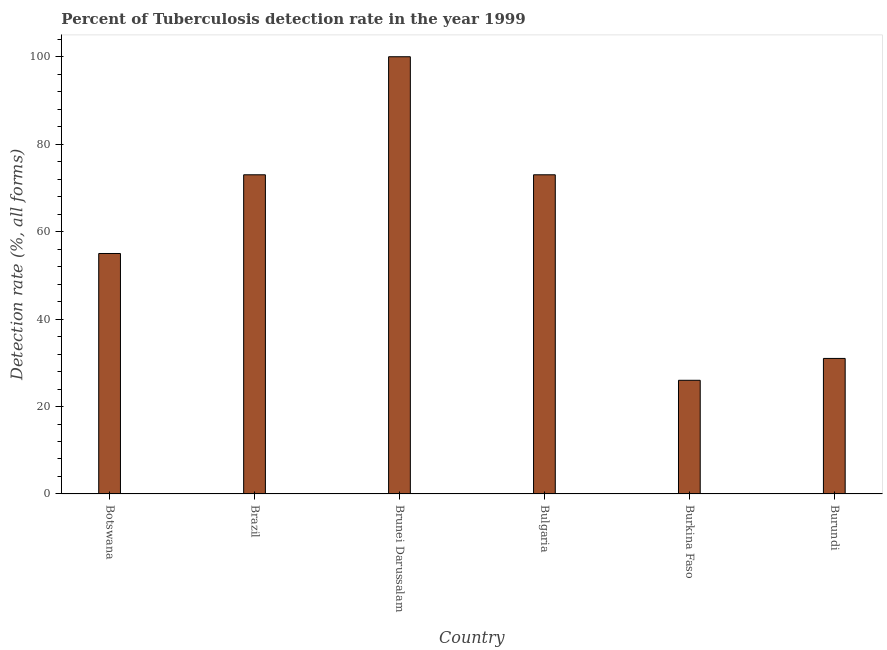Does the graph contain any zero values?
Offer a terse response. No. Does the graph contain grids?
Your answer should be very brief. No. What is the title of the graph?
Ensure brevity in your answer.  Percent of Tuberculosis detection rate in the year 1999. What is the label or title of the Y-axis?
Provide a short and direct response. Detection rate (%, all forms). What is the detection rate of tuberculosis in Bulgaria?
Offer a very short reply. 73. Across all countries, what is the maximum detection rate of tuberculosis?
Give a very brief answer. 100. Across all countries, what is the minimum detection rate of tuberculosis?
Your answer should be very brief. 26. In which country was the detection rate of tuberculosis maximum?
Make the answer very short. Brunei Darussalam. In which country was the detection rate of tuberculosis minimum?
Make the answer very short. Burkina Faso. What is the sum of the detection rate of tuberculosis?
Offer a very short reply. 358. What is the difference between the detection rate of tuberculosis in Botswana and Brunei Darussalam?
Your response must be concise. -45. What is the average detection rate of tuberculosis per country?
Offer a terse response. 59.67. What is the median detection rate of tuberculosis?
Offer a terse response. 64. In how many countries, is the detection rate of tuberculosis greater than 36 %?
Provide a short and direct response. 4. What is the ratio of the detection rate of tuberculosis in Botswana to that in Bulgaria?
Give a very brief answer. 0.75. What is the difference between the highest and the lowest detection rate of tuberculosis?
Your response must be concise. 74. In how many countries, is the detection rate of tuberculosis greater than the average detection rate of tuberculosis taken over all countries?
Give a very brief answer. 3. How many bars are there?
Your response must be concise. 6. How many countries are there in the graph?
Your response must be concise. 6. What is the difference between two consecutive major ticks on the Y-axis?
Provide a succinct answer. 20. What is the Detection rate (%, all forms) of Brazil?
Give a very brief answer. 73. What is the Detection rate (%, all forms) of Burkina Faso?
Offer a terse response. 26. What is the Detection rate (%, all forms) of Burundi?
Provide a succinct answer. 31. What is the difference between the Detection rate (%, all forms) in Botswana and Brunei Darussalam?
Ensure brevity in your answer.  -45. What is the difference between the Detection rate (%, all forms) in Botswana and Bulgaria?
Make the answer very short. -18. What is the difference between the Detection rate (%, all forms) in Botswana and Burkina Faso?
Your answer should be compact. 29. What is the difference between the Detection rate (%, all forms) in Brazil and Burundi?
Offer a terse response. 42. What is the difference between the Detection rate (%, all forms) in Brunei Darussalam and Bulgaria?
Your answer should be compact. 27. What is the difference between the Detection rate (%, all forms) in Brunei Darussalam and Burkina Faso?
Make the answer very short. 74. What is the difference between the Detection rate (%, all forms) in Brunei Darussalam and Burundi?
Your answer should be very brief. 69. What is the difference between the Detection rate (%, all forms) in Bulgaria and Burundi?
Provide a short and direct response. 42. What is the difference between the Detection rate (%, all forms) in Burkina Faso and Burundi?
Provide a short and direct response. -5. What is the ratio of the Detection rate (%, all forms) in Botswana to that in Brazil?
Your response must be concise. 0.75. What is the ratio of the Detection rate (%, all forms) in Botswana to that in Brunei Darussalam?
Make the answer very short. 0.55. What is the ratio of the Detection rate (%, all forms) in Botswana to that in Bulgaria?
Your answer should be compact. 0.75. What is the ratio of the Detection rate (%, all forms) in Botswana to that in Burkina Faso?
Keep it short and to the point. 2.12. What is the ratio of the Detection rate (%, all forms) in Botswana to that in Burundi?
Your answer should be very brief. 1.77. What is the ratio of the Detection rate (%, all forms) in Brazil to that in Brunei Darussalam?
Your answer should be very brief. 0.73. What is the ratio of the Detection rate (%, all forms) in Brazil to that in Bulgaria?
Your answer should be very brief. 1. What is the ratio of the Detection rate (%, all forms) in Brazil to that in Burkina Faso?
Make the answer very short. 2.81. What is the ratio of the Detection rate (%, all forms) in Brazil to that in Burundi?
Give a very brief answer. 2.35. What is the ratio of the Detection rate (%, all forms) in Brunei Darussalam to that in Bulgaria?
Ensure brevity in your answer.  1.37. What is the ratio of the Detection rate (%, all forms) in Brunei Darussalam to that in Burkina Faso?
Give a very brief answer. 3.85. What is the ratio of the Detection rate (%, all forms) in Brunei Darussalam to that in Burundi?
Provide a short and direct response. 3.23. What is the ratio of the Detection rate (%, all forms) in Bulgaria to that in Burkina Faso?
Your answer should be compact. 2.81. What is the ratio of the Detection rate (%, all forms) in Bulgaria to that in Burundi?
Ensure brevity in your answer.  2.35. What is the ratio of the Detection rate (%, all forms) in Burkina Faso to that in Burundi?
Your response must be concise. 0.84. 